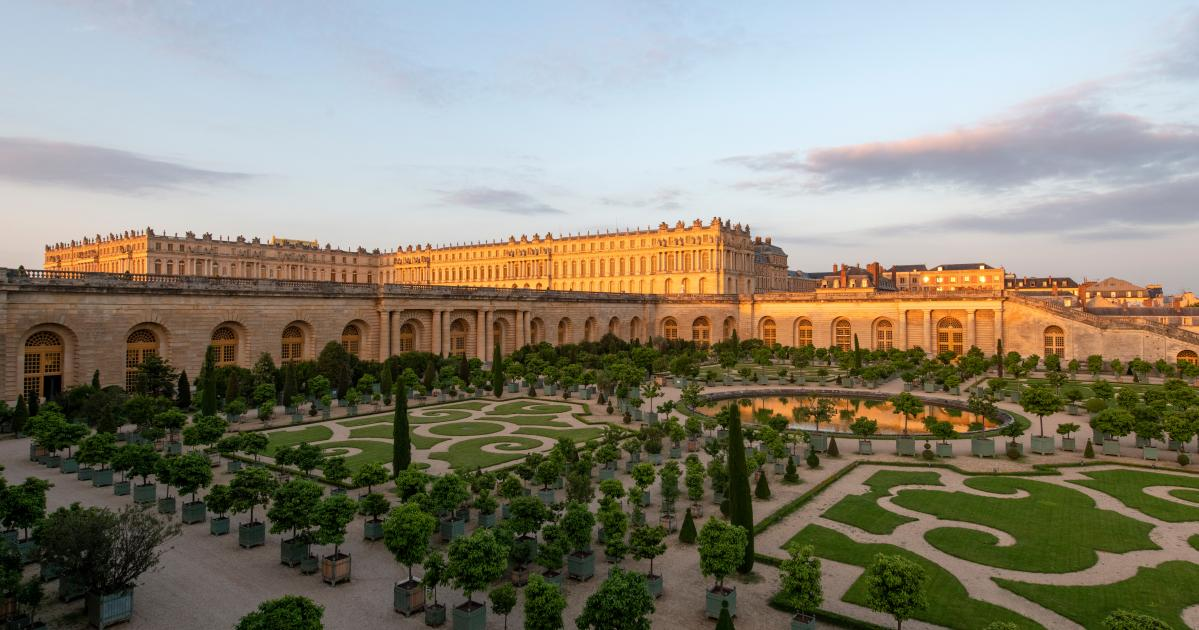Imagine the garden comes to life at night with magical creatures. Describe this scene. As night falls over the Palace of Versailles, the gardens transform into an enchanted realm. Glowing fireflies flit among the topiaries, casting a soft, ethereal light. Tunnels of shimmering vines appear where there were none before, leading to secret grottos filled with twinkling lights. Legendary creatures like unicorns and fairies emerge, their laughter and soft whispers filling the air. The fountain sparkles with what looks like liquid starlight, and the statues around the garden come to life, gracefully dancing to an invisible symphony. The entire scene feels like a dream come to life, a magical spectacle that captivates the heart and soul. 